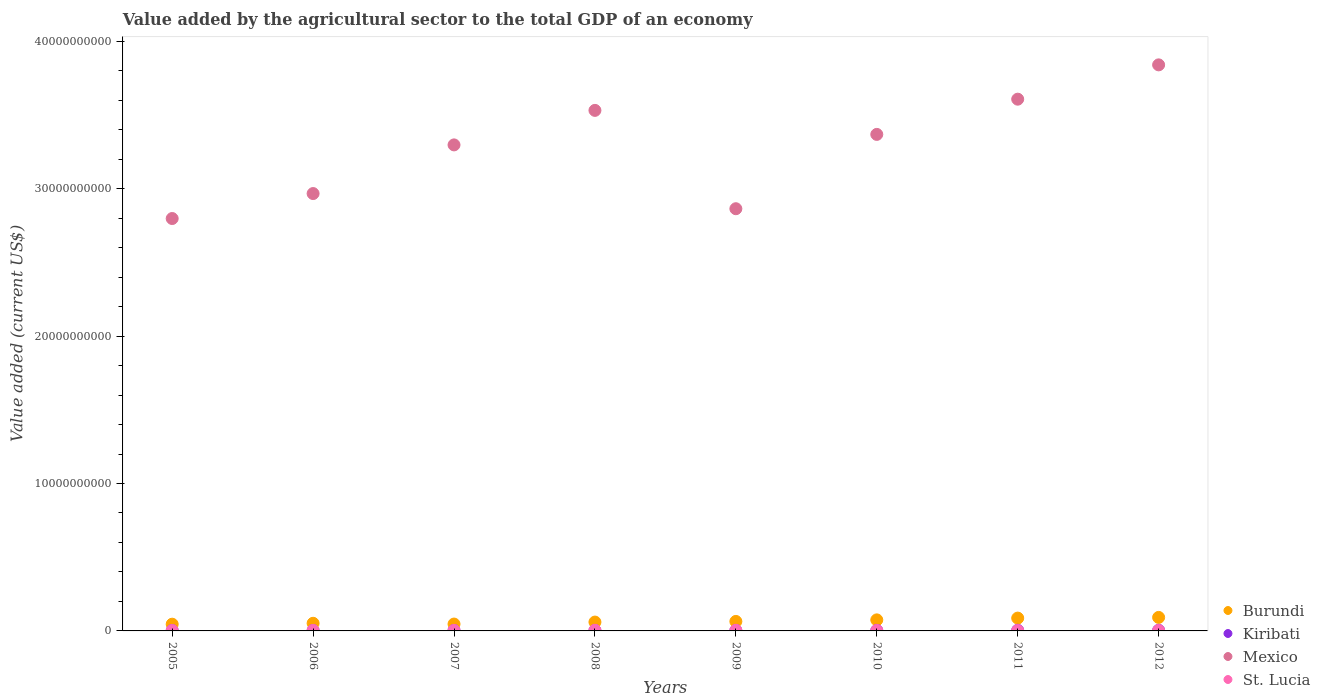Is the number of dotlines equal to the number of legend labels?
Your response must be concise. Yes. What is the value added by the agricultural sector to the total GDP in Kiribati in 2005?
Give a very brief answer. 2.30e+07. Across all years, what is the maximum value added by the agricultural sector to the total GDP in Kiribati?
Provide a succinct answer. 4.35e+07. Across all years, what is the minimum value added by the agricultural sector to the total GDP in St. Lucia?
Your answer should be very brief. 2.80e+07. In which year was the value added by the agricultural sector to the total GDP in Burundi maximum?
Your answer should be very brief. 2012. What is the total value added by the agricultural sector to the total GDP in Burundi in the graph?
Ensure brevity in your answer.  5.22e+09. What is the difference between the value added by the agricultural sector to the total GDP in Kiribati in 2005 and that in 2010?
Keep it short and to the point. -1.31e+07. What is the difference between the value added by the agricultural sector to the total GDP in Mexico in 2006 and the value added by the agricultural sector to the total GDP in Kiribati in 2011?
Offer a terse response. 2.96e+1. What is the average value added by the agricultural sector to the total GDP in Mexico per year?
Keep it short and to the point. 3.28e+1. In the year 2009, what is the difference between the value added by the agricultural sector to the total GDP in Kiribati and value added by the agricultural sector to the total GDP in Burundi?
Provide a succinct answer. -6.13e+08. What is the ratio of the value added by the agricultural sector to the total GDP in Burundi in 2007 to that in 2010?
Your answer should be compact. 0.62. Is the difference between the value added by the agricultural sector to the total GDP in Kiribati in 2010 and 2012 greater than the difference between the value added by the agricultural sector to the total GDP in Burundi in 2010 and 2012?
Your answer should be very brief. Yes. What is the difference between the highest and the second highest value added by the agricultural sector to the total GDP in Burundi?
Provide a short and direct response. 4.72e+07. What is the difference between the highest and the lowest value added by the agricultural sector to the total GDP in St. Lucia?
Your answer should be compact. 1.63e+07. Is it the case that in every year, the sum of the value added by the agricultural sector to the total GDP in St. Lucia and value added by the agricultural sector to the total GDP in Burundi  is greater than the sum of value added by the agricultural sector to the total GDP in Kiribati and value added by the agricultural sector to the total GDP in Mexico?
Make the answer very short. No. Is it the case that in every year, the sum of the value added by the agricultural sector to the total GDP in St. Lucia and value added by the agricultural sector to the total GDP in Kiribati  is greater than the value added by the agricultural sector to the total GDP in Burundi?
Provide a short and direct response. No. Does the value added by the agricultural sector to the total GDP in St. Lucia monotonically increase over the years?
Provide a short and direct response. No. Is the value added by the agricultural sector to the total GDP in Kiribati strictly greater than the value added by the agricultural sector to the total GDP in Burundi over the years?
Offer a terse response. No. Is the value added by the agricultural sector to the total GDP in St. Lucia strictly less than the value added by the agricultural sector to the total GDP in Mexico over the years?
Your response must be concise. Yes. What is the difference between two consecutive major ticks on the Y-axis?
Your answer should be compact. 1.00e+1. Are the values on the major ticks of Y-axis written in scientific E-notation?
Keep it short and to the point. No. Where does the legend appear in the graph?
Your response must be concise. Bottom right. How many legend labels are there?
Offer a terse response. 4. What is the title of the graph?
Offer a terse response. Value added by the agricultural sector to the total GDP of an economy. Does "Europe(all income levels)" appear as one of the legend labels in the graph?
Give a very brief answer. No. What is the label or title of the Y-axis?
Offer a very short reply. Value added (current US$). What is the Value added (current US$) in Burundi in 2005?
Keep it short and to the point. 4.56e+08. What is the Value added (current US$) of Kiribati in 2005?
Keep it short and to the point. 2.30e+07. What is the Value added (current US$) in Mexico in 2005?
Provide a succinct answer. 2.80e+1. What is the Value added (current US$) in St. Lucia in 2005?
Your response must be concise. 2.80e+07. What is the Value added (current US$) in Burundi in 2006?
Give a very brief answer. 5.17e+08. What is the Value added (current US$) of Kiribati in 2006?
Offer a very short reply. 2.31e+07. What is the Value added (current US$) in Mexico in 2006?
Make the answer very short. 2.97e+1. What is the Value added (current US$) in St. Lucia in 2006?
Keep it short and to the point. 3.25e+07. What is the Value added (current US$) of Burundi in 2007?
Your answer should be very brief. 4.66e+08. What is the Value added (current US$) in Kiribati in 2007?
Your response must be concise. 2.83e+07. What is the Value added (current US$) in Mexico in 2007?
Keep it short and to the point. 3.30e+1. What is the Value added (current US$) in St. Lucia in 2007?
Offer a terse response. 3.23e+07. What is the Value added (current US$) in Burundi in 2008?
Your response must be concise. 6.00e+08. What is the Value added (current US$) in Kiribati in 2008?
Ensure brevity in your answer.  3.30e+07. What is the Value added (current US$) of Mexico in 2008?
Offer a very short reply. 3.53e+1. What is the Value added (current US$) in St. Lucia in 2008?
Provide a short and direct response. 4.43e+07. What is the Value added (current US$) in Burundi in 2009?
Provide a short and direct response. 6.44e+08. What is the Value added (current US$) in Kiribati in 2009?
Ensure brevity in your answer.  3.06e+07. What is the Value added (current US$) in Mexico in 2009?
Ensure brevity in your answer.  2.86e+1. What is the Value added (current US$) of St. Lucia in 2009?
Make the answer very short. 4.25e+07. What is the Value added (current US$) in Burundi in 2010?
Keep it short and to the point. 7.49e+08. What is the Value added (current US$) in Kiribati in 2010?
Keep it short and to the point. 3.61e+07. What is the Value added (current US$) of Mexico in 2010?
Ensure brevity in your answer.  3.37e+1. What is the Value added (current US$) in St. Lucia in 2010?
Your answer should be compact. 3.16e+07. What is the Value added (current US$) in Burundi in 2011?
Your answer should be very brief. 8.69e+08. What is the Value added (current US$) in Kiribati in 2011?
Keep it short and to the point. 4.33e+07. What is the Value added (current US$) in Mexico in 2011?
Your answer should be compact. 3.61e+1. What is the Value added (current US$) in St. Lucia in 2011?
Your answer should be very brief. 2.84e+07. What is the Value added (current US$) in Burundi in 2012?
Your response must be concise. 9.16e+08. What is the Value added (current US$) of Kiribati in 2012?
Offer a terse response. 4.35e+07. What is the Value added (current US$) in Mexico in 2012?
Keep it short and to the point. 3.84e+1. What is the Value added (current US$) of St. Lucia in 2012?
Give a very brief answer. 3.24e+07. Across all years, what is the maximum Value added (current US$) of Burundi?
Your response must be concise. 9.16e+08. Across all years, what is the maximum Value added (current US$) in Kiribati?
Give a very brief answer. 4.35e+07. Across all years, what is the maximum Value added (current US$) in Mexico?
Your answer should be compact. 3.84e+1. Across all years, what is the maximum Value added (current US$) of St. Lucia?
Make the answer very short. 4.43e+07. Across all years, what is the minimum Value added (current US$) of Burundi?
Provide a succinct answer. 4.56e+08. Across all years, what is the minimum Value added (current US$) in Kiribati?
Your answer should be compact. 2.30e+07. Across all years, what is the minimum Value added (current US$) of Mexico?
Offer a very short reply. 2.80e+1. Across all years, what is the minimum Value added (current US$) in St. Lucia?
Provide a short and direct response. 2.80e+07. What is the total Value added (current US$) in Burundi in the graph?
Give a very brief answer. 5.22e+09. What is the total Value added (current US$) in Kiribati in the graph?
Your answer should be very brief. 2.61e+08. What is the total Value added (current US$) of Mexico in the graph?
Offer a terse response. 2.63e+11. What is the total Value added (current US$) of St. Lucia in the graph?
Make the answer very short. 2.72e+08. What is the difference between the Value added (current US$) of Burundi in 2005 and that in 2006?
Give a very brief answer. -6.11e+07. What is the difference between the Value added (current US$) in Kiribati in 2005 and that in 2006?
Your response must be concise. -1.69e+05. What is the difference between the Value added (current US$) of Mexico in 2005 and that in 2006?
Offer a very short reply. -1.69e+09. What is the difference between the Value added (current US$) in St. Lucia in 2005 and that in 2006?
Keep it short and to the point. -4.56e+06. What is the difference between the Value added (current US$) of Burundi in 2005 and that in 2007?
Keep it short and to the point. -9.49e+06. What is the difference between the Value added (current US$) in Kiribati in 2005 and that in 2007?
Offer a terse response. -5.39e+06. What is the difference between the Value added (current US$) in Mexico in 2005 and that in 2007?
Provide a succinct answer. -4.99e+09. What is the difference between the Value added (current US$) in St. Lucia in 2005 and that in 2007?
Offer a very short reply. -4.31e+06. What is the difference between the Value added (current US$) of Burundi in 2005 and that in 2008?
Ensure brevity in your answer.  -1.44e+08. What is the difference between the Value added (current US$) in Kiribati in 2005 and that in 2008?
Keep it short and to the point. -1.01e+07. What is the difference between the Value added (current US$) in Mexico in 2005 and that in 2008?
Offer a very short reply. -7.34e+09. What is the difference between the Value added (current US$) in St. Lucia in 2005 and that in 2008?
Your response must be concise. -1.63e+07. What is the difference between the Value added (current US$) in Burundi in 2005 and that in 2009?
Offer a terse response. -1.87e+08. What is the difference between the Value added (current US$) in Kiribati in 2005 and that in 2009?
Provide a succinct answer. -7.61e+06. What is the difference between the Value added (current US$) of Mexico in 2005 and that in 2009?
Your answer should be very brief. -6.65e+08. What is the difference between the Value added (current US$) of St. Lucia in 2005 and that in 2009?
Give a very brief answer. -1.45e+07. What is the difference between the Value added (current US$) in Burundi in 2005 and that in 2010?
Your response must be concise. -2.93e+08. What is the difference between the Value added (current US$) of Kiribati in 2005 and that in 2010?
Offer a very short reply. -1.31e+07. What is the difference between the Value added (current US$) of Mexico in 2005 and that in 2010?
Your answer should be very brief. -5.71e+09. What is the difference between the Value added (current US$) of St. Lucia in 2005 and that in 2010?
Make the answer very short. -3.60e+06. What is the difference between the Value added (current US$) in Burundi in 2005 and that in 2011?
Make the answer very short. -4.13e+08. What is the difference between the Value added (current US$) of Kiribati in 2005 and that in 2011?
Provide a short and direct response. -2.04e+07. What is the difference between the Value added (current US$) of Mexico in 2005 and that in 2011?
Keep it short and to the point. -8.10e+09. What is the difference between the Value added (current US$) of St. Lucia in 2005 and that in 2011?
Offer a terse response. -3.88e+05. What is the difference between the Value added (current US$) in Burundi in 2005 and that in 2012?
Provide a succinct answer. -4.60e+08. What is the difference between the Value added (current US$) in Kiribati in 2005 and that in 2012?
Make the answer very short. -2.05e+07. What is the difference between the Value added (current US$) in Mexico in 2005 and that in 2012?
Your answer should be very brief. -1.04e+1. What is the difference between the Value added (current US$) of St. Lucia in 2005 and that in 2012?
Give a very brief answer. -4.44e+06. What is the difference between the Value added (current US$) in Burundi in 2006 and that in 2007?
Give a very brief answer. 5.16e+07. What is the difference between the Value added (current US$) in Kiribati in 2006 and that in 2007?
Offer a terse response. -5.23e+06. What is the difference between the Value added (current US$) of Mexico in 2006 and that in 2007?
Give a very brief answer. -3.30e+09. What is the difference between the Value added (current US$) in St. Lucia in 2006 and that in 2007?
Your answer should be very brief. 2.52e+05. What is the difference between the Value added (current US$) in Burundi in 2006 and that in 2008?
Make the answer very short. -8.27e+07. What is the difference between the Value added (current US$) of Kiribati in 2006 and that in 2008?
Your answer should be very brief. -9.93e+06. What is the difference between the Value added (current US$) in Mexico in 2006 and that in 2008?
Provide a succinct answer. -5.64e+09. What is the difference between the Value added (current US$) in St. Lucia in 2006 and that in 2008?
Your response must be concise. -1.17e+07. What is the difference between the Value added (current US$) of Burundi in 2006 and that in 2009?
Provide a succinct answer. -1.26e+08. What is the difference between the Value added (current US$) of Kiribati in 2006 and that in 2009?
Offer a very short reply. -7.44e+06. What is the difference between the Value added (current US$) in Mexico in 2006 and that in 2009?
Provide a succinct answer. 1.03e+09. What is the difference between the Value added (current US$) of St. Lucia in 2006 and that in 2009?
Make the answer very short. -9.91e+06. What is the difference between the Value added (current US$) of Burundi in 2006 and that in 2010?
Your answer should be very brief. -2.32e+08. What is the difference between the Value added (current US$) of Kiribati in 2006 and that in 2010?
Make the answer very short. -1.29e+07. What is the difference between the Value added (current US$) in Mexico in 2006 and that in 2010?
Your response must be concise. -4.01e+09. What is the difference between the Value added (current US$) in St. Lucia in 2006 and that in 2010?
Provide a short and direct response. 9.56e+05. What is the difference between the Value added (current US$) in Burundi in 2006 and that in 2011?
Ensure brevity in your answer.  -3.52e+08. What is the difference between the Value added (current US$) of Kiribati in 2006 and that in 2011?
Your answer should be very brief. -2.02e+07. What is the difference between the Value added (current US$) in Mexico in 2006 and that in 2011?
Your response must be concise. -6.40e+09. What is the difference between the Value added (current US$) of St. Lucia in 2006 and that in 2011?
Keep it short and to the point. 4.17e+06. What is the difference between the Value added (current US$) of Burundi in 2006 and that in 2012?
Offer a very short reply. -3.99e+08. What is the difference between the Value added (current US$) in Kiribati in 2006 and that in 2012?
Ensure brevity in your answer.  -2.04e+07. What is the difference between the Value added (current US$) of Mexico in 2006 and that in 2012?
Your answer should be compact. -8.73e+09. What is the difference between the Value added (current US$) of St. Lucia in 2006 and that in 2012?
Your response must be concise. 1.19e+05. What is the difference between the Value added (current US$) of Burundi in 2007 and that in 2008?
Give a very brief answer. -1.34e+08. What is the difference between the Value added (current US$) of Kiribati in 2007 and that in 2008?
Keep it short and to the point. -4.70e+06. What is the difference between the Value added (current US$) in Mexico in 2007 and that in 2008?
Your answer should be compact. -2.34e+09. What is the difference between the Value added (current US$) of St. Lucia in 2007 and that in 2008?
Your answer should be very brief. -1.20e+07. What is the difference between the Value added (current US$) in Burundi in 2007 and that in 2009?
Your answer should be compact. -1.78e+08. What is the difference between the Value added (current US$) of Kiribati in 2007 and that in 2009?
Keep it short and to the point. -2.21e+06. What is the difference between the Value added (current US$) of Mexico in 2007 and that in 2009?
Give a very brief answer. 4.33e+09. What is the difference between the Value added (current US$) in St. Lucia in 2007 and that in 2009?
Your answer should be very brief. -1.02e+07. What is the difference between the Value added (current US$) of Burundi in 2007 and that in 2010?
Offer a terse response. -2.83e+08. What is the difference between the Value added (current US$) of Kiribati in 2007 and that in 2010?
Offer a terse response. -7.71e+06. What is the difference between the Value added (current US$) of Mexico in 2007 and that in 2010?
Offer a terse response. -7.12e+08. What is the difference between the Value added (current US$) in St. Lucia in 2007 and that in 2010?
Your response must be concise. 7.04e+05. What is the difference between the Value added (current US$) in Burundi in 2007 and that in 2011?
Provide a short and direct response. -4.03e+08. What is the difference between the Value added (current US$) of Kiribati in 2007 and that in 2011?
Ensure brevity in your answer.  -1.50e+07. What is the difference between the Value added (current US$) in Mexico in 2007 and that in 2011?
Make the answer very short. -3.10e+09. What is the difference between the Value added (current US$) in St. Lucia in 2007 and that in 2011?
Ensure brevity in your answer.  3.92e+06. What is the difference between the Value added (current US$) in Burundi in 2007 and that in 2012?
Offer a very short reply. -4.51e+08. What is the difference between the Value added (current US$) in Kiribati in 2007 and that in 2012?
Your answer should be compact. -1.51e+07. What is the difference between the Value added (current US$) of Mexico in 2007 and that in 2012?
Your answer should be compact. -5.43e+09. What is the difference between the Value added (current US$) of St. Lucia in 2007 and that in 2012?
Make the answer very short. -1.34e+05. What is the difference between the Value added (current US$) of Burundi in 2008 and that in 2009?
Provide a succinct answer. -4.35e+07. What is the difference between the Value added (current US$) of Kiribati in 2008 and that in 2009?
Give a very brief answer. 2.49e+06. What is the difference between the Value added (current US$) in Mexico in 2008 and that in 2009?
Your answer should be very brief. 6.67e+09. What is the difference between the Value added (current US$) in St. Lucia in 2008 and that in 2009?
Make the answer very short. 1.83e+06. What is the difference between the Value added (current US$) of Burundi in 2008 and that in 2010?
Provide a succinct answer. -1.49e+08. What is the difference between the Value added (current US$) in Kiribati in 2008 and that in 2010?
Provide a short and direct response. -3.01e+06. What is the difference between the Value added (current US$) of Mexico in 2008 and that in 2010?
Offer a terse response. 1.63e+09. What is the difference between the Value added (current US$) in St. Lucia in 2008 and that in 2010?
Give a very brief answer. 1.27e+07. What is the difference between the Value added (current US$) in Burundi in 2008 and that in 2011?
Provide a short and direct response. -2.69e+08. What is the difference between the Value added (current US$) of Kiribati in 2008 and that in 2011?
Provide a short and direct response. -1.03e+07. What is the difference between the Value added (current US$) of Mexico in 2008 and that in 2011?
Your answer should be compact. -7.60e+08. What is the difference between the Value added (current US$) in St. Lucia in 2008 and that in 2011?
Keep it short and to the point. 1.59e+07. What is the difference between the Value added (current US$) of Burundi in 2008 and that in 2012?
Your answer should be very brief. -3.16e+08. What is the difference between the Value added (current US$) in Kiribati in 2008 and that in 2012?
Your answer should be very brief. -1.04e+07. What is the difference between the Value added (current US$) in Mexico in 2008 and that in 2012?
Your response must be concise. -3.09e+09. What is the difference between the Value added (current US$) of St. Lucia in 2008 and that in 2012?
Your response must be concise. 1.19e+07. What is the difference between the Value added (current US$) of Burundi in 2009 and that in 2010?
Your answer should be compact. -1.06e+08. What is the difference between the Value added (current US$) of Kiribati in 2009 and that in 2010?
Keep it short and to the point. -5.49e+06. What is the difference between the Value added (current US$) of Mexico in 2009 and that in 2010?
Your answer should be compact. -5.04e+09. What is the difference between the Value added (current US$) in St. Lucia in 2009 and that in 2010?
Give a very brief answer. 1.09e+07. What is the difference between the Value added (current US$) in Burundi in 2009 and that in 2011?
Ensure brevity in your answer.  -2.26e+08. What is the difference between the Value added (current US$) of Kiribati in 2009 and that in 2011?
Your answer should be compact. -1.28e+07. What is the difference between the Value added (current US$) in Mexico in 2009 and that in 2011?
Offer a terse response. -7.43e+09. What is the difference between the Value added (current US$) of St. Lucia in 2009 and that in 2011?
Offer a very short reply. 1.41e+07. What is the difference between the Value added (current US$) in Burundi in 2009 and that in 2012?
Your response must be concise. -2.73e+08. What is the difference between the Value added (current US$) in Kiribati in 2009 and that in 2012?
Ensure brevity in your answer.  -1.29e+07. What is the difference between the Value added (current US$) in Mexico in 2009 and that in 2012?
Provide a short and direct response. -9.76e+09. What is the difference between the Value added (current US$) of St. Lucia in 2009 and that in 2012?
Give a very brief answer. 1.00e+07. What is the difference between the Value added (current US$) of Burundi in 2010 and that in 2011?
Ensure brevity in your answer.  -1.20e+08. What is the difference between the Value added (current US$) in Kiribati in 2010 and that in 2011?
Keep it short and to the point. -7.26e+06. What is the difference between the Value added (current US$) of Mexico in 2010 and that in 2011?
Offer a terse response. -2.39e+09. What is the difference between the Value added (current US$) of St. Lucia in 2010 and that in 2011?
Make the answer very short. 3.22e+06. What is the difference between the Value added (current US$) in Burundi in 2010 and that in 2012?
Make the answer very short. -1.67e+08. What is the difference between the Value added (current US$) of Kiribati in 2010 and that in 2012?
Make the answer very short. -7.43e+06. What is the difference between the Value added (current US$) in Mexico in 2010 and that in 2012?
Provide a succinct answer. -4.72e+09. What is the difference between the Value added (current US$) of St. Lucia in 2010 and that in 2012?
Keep it short and to the point. -8.38e+05. What is the difference between the Value added (current US$) in Burundi in 2011 and that in 2012?
Your answer should be compact. -4.72e+07. What is the difference between the Value added (current US$) in Kiribati in 2011 and that in 2012?
Give a very brief answer. -1.66e+05. What is the difference between the Value added (current US$) of Mexico in 2011 and that in 2012?
Provide a succinct answer. -2.33e+09. What is the difference between the Value added (current US$) in St. Lucia in 2011 and that in 2012?
Provide a succinct answer. -4.05e+06. What is the difference between the Value added (current US$) in Burundi in 2005 and the Value added (current US$) in Kiribati in 2006?
Ensure brevity in your answer.  4.33e+08. What is the difference between the Value added (current US$) of Burundi in 2005 and the Value added (current US$) of Mexico in 2006?
Offer a terse response. -2.92e+1. What is the difference between the Value added (current US$) of Burundi in 2005 and the Value added (current US$) of St. Lucia in 2006?
Your answer should be compact. 4.24e+08. What is the difference between the Value added (current US$) in Kiribati in 2005 and the Value added (current US$) in Mexico in 2006?
Give a very brief answer. -2.96e+1. What is the difference between the Value added (current US$) in Kiribati in 2005 and the Value added (current US$) in St. Lucia in 2006?
Offer a terse response. -9.59e+06. What is the difference between the Value added (current US$) in Mexico in 2005 and the Value added (current US$) in St. Lucia in 2006?
Offer a terse response. 2.79e+1. What is the difference between the Value added (current US$) of Burundi in 2005 and the Value added (current US$) of Kiribati in 2007?
Your answer should be compact. 4.28e+08. What is the difference between the Value added (current US$) in Burundi in 2005 and the Value added (current US$) in Mexico in 2007?
Provide a short and direct response. -3.25e+1. What is the difference between the Value added (current US$) in Burundi in 2005 and the Value added (current US$) in St. Lucia in 2007?
Make the answer very short. 4.24e+08. What is the difference between the Value added (current US$) in Kiribati in 2005 and the Value added (current US$) in Mexico in 2007?
Ensure brevity in your answer.  -3.29e+1. What is the difference between the Value added (current US$) in Kiribati in 2005 and the Value added (current US$) in St. Lucia in 2007?
Provide a succinct answer. -9.34e+06. What is the difference between the Value added (current US$) in Mexico in 2005 and the Value added (current US$) in St. Lucia in 2007?
Your answer should be compact. 2.79e+1. What is the difference between the Value added (current US$) in Burundi in 2005 and the Value added (current US$) in Kiribati in 2008?
Your answer should be compact. 4.23e+08. What is the difference between the Value added (current US$) in Burundi in 2005 and the Value added (current US$) in Mexico in 2008?
Your answer should be very brief. -3.49e+1. What is the difference between the Value added (current US$) in Burundi in 2005 and the Value added (current US$) in St. Lucia in 2008?
Make the answer very short. 4.12e+08. What is the difference between the Value added (current US$) of Kiribati in 2005 and the Value added (current US$) of Mexico in 2008?
Your response must be concise. -3.53e+1. What is the difference between the Value added (current US$) of Kiribati in 2005 and the Value added (current US$) of St. Lucia in 2008?
Your response must be concise. -2.13e+07. What is the difference between the Value added (current US$) of Mexico in 2005 and the Value added (current US$) of St. Lucia in 2008?
Your answer should be compact. 2.79e+1. What is the difference between the Value added (current US$) of Burundi in 2005 and the Value added (current US$) of Kiribati in 2009?
Provide a succinct answer. 4.26e+08. What is the difference between the Value added (current US$) in Burundi in 2005 and the Value added (current US$) in Mexico in 2009?
Your answer should be very brief. -2.82e+1. What is the difference between the Value added (current US$) in Burundi in 2005 and the Value added (current US$) in St. Lucia in 2009?
Give a very brief answer. 4.14e+08. What is the difference between the Value added (current US$) in Kiribati in 2005 and the Value added (current US$) in Mexico in 2009?
Your answer should be very brief. -2.86e+1. What is the difference between the Value added (current US$) of Kiribati in 2005 and the Value added (current US$) of St. Lucia in 2009?
Offer a terse response. -1.95e+07. What is the difference between the Value added (current US$) in Mexico in 2005 and the Value added (current US$) in St. Lucia in 2009?
Provide a short and direct response. 2.79e+1. What is the difference between the Value added (current US$) of Burundi in 2005 and the Value added (current US$) of Kiribati in 2010?
Offer a very short reply. 4.20e+08. What is the difference between the Value added (current US$) in Burundi in 2005 and the Value added (current US$) in Mexico in 2010?
Provide a succinct answer. -3.32e+1. What is the difference between the Value added (current US$) in Burundi in 2005 and the Value added (current US$) in St. Lucia in 2010?
Ensure brevity in your answer.  4.25e+08. What is the difference between the Value added (current US$) in Kiribati in 2005 and the Value added (current US$) in Mexico in 2010?
Your answer should be very brief. -3.37e+1. What is the difference between the Value added (current US$) in Kiribati in 2005 and the Value added (current US$) in St. Lucia in 2010?
Give a very brief answer. -8.63e+06. What is the difference between the Value added (current US$) of Mexico in 2005 and the Value added (current US$) of St. Lucia in 2010?
Your response must be concise. 2.79e+1. What is the difference between the Value added (current US$) in Burundi in 2005 and the Value added (current US$) in Kiribati in 2011?
Your answer should be very brief. 4.13e+08. What is the difference between the Value added (current US$) in Burundi in 2005 and the Value added (current US$) in Mexico in 2011?
Provide a succinct answer. -3.56e+1. What is the difference between the Value added (current US$) of Burundi in 2005 and the Value added (current US$) of St. Lucia in 2011?
Provide a succinct answer. 4.28e+08. What is the difference between the Value added (current US$) of Kiribati in 2005 and the Value added (current US$) of Mexico in 2011?
Provide a succinct answer. -3.60e+1. What is the difference between the Value added (current US$) in Kiribati in 2005 and the Value added (current US$) in St. Lucia in 2011?
Keep it short and to the point. -5.42e+06. What is the difference between the Value added (current US$) in Mexico in 2005 and the Value added (current US$) in St. Lucia in 2011?
Ensure brevity in your answer.  2.79e+1. What is the difference between the Value added (current US$) in Burundi in 2005 and the Value added (current US$) in Kiribati in 2012?
Provide a succinct answer. 4.13e+08. What is the difference between the Value added (current US$) in Burundi in 2005 and the Value added (current US$) in Mexico in 2012?
Give a very brief answer. -3.79e+1. What is the difference between the Value added (current US$) in Burundi in 2005 and the Value added (current US$) in St. Lucia in 2012?
Make the answer very short. 4.24e+08. What is the difference between the Value added (current US$) in Kiribati in 2005 and the Value added (current US$) in Mexico in 2012?
Your answer should be compact. -3.84e+1. What is the difference between the Value added (current US$) in Kiribati in 2005 and the Value added (current US$) in St. Lucia in 2012?
Your response must be concise. -9.47e+06. What is the difference between the Value added (current US$) in Mexico in 2005 and the Value added (current US$) in St. Lucia in 2012?
Offer a very short reply. 2.79e+1. What is the difference between the Value added (current US$) in Burundi in 2006 and the Value added (current US$) in Kiribati in 2007?
Make the answer very short. 4.89e+08. What is the difference between the Value added (current US$) of Burundi in 2006 and the Value added (current US$) of Mexico in 2007?
Give a very brief answer. -3.25e+1. What is the difference between the Value added (current US$) in Burundi in 2006 and the Value added (current US$) in St. Lucia in 2007?
Provide a succinct answer. 4.85e+08. What is the difference between the Value added (current US$) of Kiribati in 2006 and the Value added (current US$) of Mexico in 2007?
Keep it short and to the point. -3.29e+1. What is the difference between the Value added (current US$) of Kiribati in 2006 and the Value added (current US$) of St. Lucia in 2007?
Offer a terse response. -9.17e+06. What is the difference between the Value added (current US$) of Mexico in 2006 and the Value added (current US$) of St. Lucia in 2007?
Your answer should be very brief. 2.96e+1. What is the difference between the Value added (current US$) of Burundi in 2006 and the Value added (current US$) of Kiribati in 2008?
Keep it short and to the point. 4.84e+08. What is the difference between the Value added (current US$) of Burundi in 2006 and the Value added (current US$) of Mexico in 2008?
Your answer should be compact. -3.48e+1. What is the difference between the Value added (current US$) of Burundi in 2006 and the Value added (current US$) of St. Lucia in 2008?
Give a very brief answer. 4.73e+08. What is the difference between the Value added (current US$) of Kiribati in 2006 and the Value added (current US$) of Mexico in 2008?
Make the answer very short. -3.53e+1. What is the difference between the Value added (current US$) of Kiribati in 2006 and the Value added (current US$) of St. Lucia in 2008?
Give a very brief answer. -2.12e+07. What is the difference between the Value added (current US$) of Mexico in 2006 and the Value added (current US$) of St. Lucia in 2008?
Provide a short and direct response. 2.96e+1. What is the difference between the Value added (current US$) in Burundi in 2006 and the Value added (current US$) in Kiribati in 2009?
Provide a succinct answer. 4.87e+08. What is the difference between the Value added (current US$) of Burundi in 2006 and the Value added (current US$) of Mexico in 2009?
Offer a very short reply. -2.81e+1. What is the difference between the Value added (current US$) in Burundi in 2006 and the Value added (current US$) in St. Lucia in 2009?
Your answer should be compact. 4.75e+08. What is the difference between the Value added (current US$) of Kiribati in 2006 and the Value added (current US$) of Mexico in 2009?
Provide a short and direct response. -2.86e+1. What is the difference between the Value added (current US$) of Kiribati in 2006 and the Value added (current US$) of St. Lucia in 2009?
Keep it short and to the point. -1.93e+07. What is the difference between the Value added (current US$) in Mexico in 2006 and the Value added (current US$) in St. Lucia in 2009?
Keep it short and to the point. 2.96e+1. What is the difference between the Value added (current US$) of Burundi in 2006 and the Value added (current US$) of Kiribati in 2010?
Provide a short and direct response. 4.81e+08. What is the difference between the Value added (current US$) of Burundi in 2006 and the Value added (current US$) of Mexico in 2010?
Ensure brevity in your answer.  -3.32e+1. What is the difference between the Value added (current US$) of Burundi in 2006 and the Value added (current US$) of St. Lucia in 2010?
Provide a succinct answer. 4.86e+08. What is the difference between the Value added (current US$) of Kiribati in 2006 and the Value added (current US$) of Mexico in 2010?
Your answer should be very brief. -3.37e+1. What is the difference between the Value added (current US$) in Kiribati in 2006 and the Value added (current US$) in St. Lucia in 2010?
Provide a short and direct response. -8.47e+06. What is the difference between the Value added (current US$) of Mexico in 2006 and the Value added (current US$) of St. Lucia in 2010?
Keep it short and to the point. 2.96e+1. What is the difference between the Value added (current US$) of Burundi in 2006 and the Value added (current US$) of Kiribati in 2011?
Provide a short and direct response. 4.74e+08. What is the difference between the Value added (current US$) of Burundi in 2006 and the Value added (current US$) of Mexico in 2011?
Your answer should be compact. -3.56e+1. What is the difference between the Value added (current US$) in Burundi in 2006 and the Value added (current US$) in St. Lucia in 2011?
Give a very brief answer. 4.89e+08. What is the difference between the Value added (current US$) in Kiribati in 2006 and the Value added (current US$) in Mexico in 2011?
Offer a terse response. -3.60e+1. What is the difference between the Value added (current US$) of Kiribati in 2006 and the Value added (current US$) of St. Lucia in 2011?
Give a very brief answer. -5.25e+06. What is the difference between the Value added (current US$) in Mexico in 2006 and the Value added (current US$) in St. Lucia in 2011?
Your answer should be very brief. 2.96e+1. What is the difference between the Value added (current US$) in Burundi in 2006 and the Value added (current US$) in Kiribati in 2012?
Offer a terse response. 4.74e+08. What is the difference between the Value added (current US$) of Burundi in 2006 and the Value added (current US$) of Mexico in 2012?
Offer a terse response. -3.79e+1. What is the difference between the Value added (current US$) of Burundi in 2006 and the Value added (current US$) of St. Lucia in 2012?
Your answer should be compact. 4.85e+08. What is the difference between the Value added (current US$) of Kiribati in 2006 and the Value added (current US$) of Mexico in 2012?
Your answer should be very brief. -3.84e+1. What is the difference between the Value added (current US$) in Kiribati in 2006 and the Value added (current US$) in St. Lucia in 2012?
Provide a short and direct response. -9.30e+06. What is the difference between the Value added (current US$) in Mexico in 2006 and the Value added (current US$) in St. Lucia in 2012?
Offer a terse response. 2.96e+1. What is the difference between the Value added (current US$) of Burundi in 2007 and the Value added (current US$) of Kiribati in 2008?
Your response must be concise. 4.33e+08. What is the difference between the Value added (current US$) of Burundi in 2007 and the Value added (current US$) of Mexico in 2008?
Give a very brief answer. -3.48e+1. What is the difference between the Value added (current US$) in Burundi in 2007 and the Value added (current US$) in St. Lucia in 2008?
Offer a terse response. 4.22e+08. What is the difference between the Value added (current US$) of Kiribati in 2007 and the Value added (current US$) of Mexico in 2008?
Your answer should be very brief. -3.53e+1. What is the difference between the Value added (current US$) in Kiribati in 2007 and the Value added (current US$) in St. Lucia in 2008?
Provide a succinct answer. -1.59e+07. What is the difference between the Value added (current US$) of Mexico in 2007 and the Value added (current US$) of St. Lucia in 2008?
Your answer should be compact. 3.29e+1. What is the difference between the Value added (current US$) of Burundi in 2007 and the Value added (current US$) of Kiribati in 2009?
Your answer should be very brief. 4.35e+08. What is the difference between the Value added (current US$) in Burundi in 2007 and the Value added (current US$) in Mexico in 2009?
Your answer should be very brief. -2.82e+1. What is the difference between the Value added (current US$) in Burundi in 2007 and the Value added (current US$) in St. Lucia in 2009?
Give a very brief answer. 4.23e+08. What is the difference between the Value added (current US$) in Kiribati in 2007 and the Value added (current US$) in Mexico in 2009?
Keep it short and to the point. -2.86e+1. What is the difference between the Value added (current US$) of Kiribati in 2007 and the Value added (current US$) of St. Lucia in 2009?
Provide a short and direct response. -1.41e+07. What is the difference between the Value added (current US$) of Mexico in 2007 and the Value added (current US$) of St. Lucia in 2009?
Give a very brief answer. 3.29e+1. What is the difference between the Value added (current US$) in Burundi in 2007 and the Value added (current US$) in Kiribati in 2010?
Your answer should be very brief. 4.30e+08. What is the difference between the Value added (current US$) in Burundi in 2007 and the Value added (current US$) in Mexico in 2010?
Provide a short and direct response. -3.32e+1. What is the difference between the Value added (current US$) in Burundi in 2007 and the Value added (current US$) in St. Lucia in 2010?
Your answer should be compact. 4.34e+08. What is the difference between the Value added (current US$) of Kiribati in 2007 and the Value added (current US$) of Mexico in 2010?
Provide a short and direct response. -3.37e+1. What is the difference between the Value added (current US$) in Kiribati in 2007 and the Value added (current US$) in St. Lucia in 2010?
Offer a terse response. -3.24e+06. What is the difference between the Value added (current US$) in Mexico in 2007 and the Value added (current US$) in St. Lucia in 2010?
Make the answer very short. 3.29e+1. What is the difference between the Value added (current US$) of Burundi in 2007 and the Value added (current US$) of Kiribati in 2011?
Your response must be concise. 4.23e+08. What is the difference between the Value added (current US$) in Burundi in 2007 and the Value added (current US$) in Mexico in 2011?
Provide a succinct answer. -3.56e+1. What is the difference between the Value added (current US$) in Burundi in 2007 and the Value added (current US$) in St. Lucia in 2011?
Make the answer very short. 4.37e+08. What is the difference between the Value added (current US$) in Kiribati in 2007 and the Value added (current US$) in Mexico in 2011?
Give a very brief answer. -3.60e+1. What is the difference between the Value added (current US$) of Kiribati in 2007 and the Value added (current US$) of St. Lucia in 2011?
Ensure brevity in your answer.  -2.45e+04. What is the difference between the Value added (current US$) of Mexico in 2007 and the Value added (current US$) of St. Lucia in 2011?
Keep it short and to the point. 3.29e+1. What is the difference between the Value added (current US$) of Burundi in 2007 and the Value added (current US$) of Kiribati in 2012?
Provide a short and direct response. 4.22e+08. What is the difference between the Value added (current US$) in Burundi in 2007 and the Value added (current US$) in Mexico in 2012?
Offer a very short reply. -3.79e+1. What is the difference between the Value added (current US$) of Burundi in 2007 and the Value added (current US$) of St. Lucia in 2012?
Offer a terse response. 4.33e+08. What is the difference between the Value added (current US$) of Kiribati in 2007 and the Value added (current US$) of Mexico in 2012?
Make the answer very short. -3.84e+1. What is the difference between the Value added (current US$) in Kiribati in 2007 and the Value added (current US$) in St. Lucia in 2012?
Offer a terse response. -4.08e+06. What is the difference between the Value added (current US$) in Mexico in 2007 and the Value added (current US$) in St. Lucia in 2012?
Offer a very short reply. 3.29e+1. What is the difference between the Value added (current US$) of Burundi in 2008 and the Value added (current US$) of Kiribati in 2009?
Offer a terse response. 5.70e+08. What is the difference between the Value added (current US$) of Burundi in 2008 and the Value added (current US$) of Mexico in 2009?
Your answer should be very brief. -2.80e+1. What is the difference between the Value added (current US$) of Burundi in 2008 and the Value added (current US$) of St. Lucia in 2009?
Make the answer very short. 5.58e+08. What is the difference between the Value added (current US$) of Kiribati in 2008 and the Value added (current US$) of Mexico in 2009?
Keep it short and to the point. -2.86e+1. What is the difference between the Value added (current US$) of Kiribati in 2008 and the Value added (current US$) of St. Lucia in 2009?
Give a very brief answer. -9.41e+06. What is the difference between the Value added (current US$) in Mexico in 2008 and the Value added (current US$) in St. Lucia in 2009?
Your answer should be very brief. 3.53e+1. What is the difference between the Value added (current US$) in Burundi in 2008 and the Value added (current US$) in Kiribati in 2010?
Make the answer very short. 5.64e+08. What is the difference between the Value added (current US$) of Burundi in 2008 and the Value added (current US$) of Mexico in 2010?
Offer a terse response. -3.31e+1. What is the difference between the Value added (current US$) in Burundi in 2008 and the Value added (current US$) in St. Lucia in 2010?
Provide a short and direct response. 5.69e+08. What is the difference between the Value added (current US$) of Kiribati in 2008 and the Value added (current US$) of Mexico in 2010?
Offer a terse response. -3.36e+1. What is the difference between the Value added (current US$) in Kiribati in 2008 and the Value added (current US$) in St. Lucia in 2010?
Keep it short and to the point. 1.46e+06. What is the difference between the Value added (current US$) in Mexico in 2008 and the Value added (current US$) in St. Lucia in 2010?
Your answer should be very brief. 3.53e+1. What is the difference between the Value added (current US$) in Burundi in 2008 and the Value added (current US$) in Kiribati in 2011?
Provide a succinct answer. 5.57e+08. What is the difference between the Value added (current US$) in Burundi in 2008 and the Value added (current US$) in Mexico in 2011?
Provide a succinct answer. -3.55e+1. What is the difference between the Value added (current US$) in Burundi in 2008 and the Value added (current US$) in St. Lucia in 2011?
Give a very brief answer. 5.72e+08. What is the difference between the Value added (current US$) in Kiribati in 2008 and the Value added (current US$) in Mexico in 2011?
Provide a succinct answer. -3.60e+1. What is the difference between the Value added (current US$) of Kiribati in 2008 and the Value added (current US$) of St. Lucia in 2011?
Your answer should be very brief. 4.68e+06. What is the difference between the Value added (current US$) of Mexico in 2008 and the Value added (current US$) of St. Lucia in 2011?
Your response must be concise. 3.53e+1. What is the difference between the Value added (current US$) in Burundi in 2008 and the Value added (current US$) in Kiribati in 2012?
Make the answer very short. 5.57e+08. What is the difference between the Value added (current US$) of Burundi in 2008 and the Value added (current US$) of Mexico in 2012?
Offer a terse response. -3.78e+1. What is the difference between the Value added (current US$) in Burundi in 2008 and the Value added (current US$) in St. Lucia in 2012?
Your response must be concise. 5.68e+08. What is the difference between the Value added (current US$) in Kiribati in 2008 and the Value added (current US$) in Mexico in 2012?
Your answer should be very brief. -3.84e+1. What is the difference between the Value added (current US$) of Kiribati in 2008 and the Value added (current US$) of St. Lucia in 2012?
Ensure brevity in your answer.  6.22e+05. What is the difference between the Value added (current US$) in Mexico in 2008 and the Value added (current US$) in St. Lucia in 2012?
Your answer should be compact. 3.53e+1. What is the difference between the Value added (current US$) in Burundi in 2009 and the Value added (current US$) in Kiribati in 2010?
Make the answer very short. 6.08e+08. What is the difference between the Value added (current US$) in Burundi in 2009 and the Value added (current US$) in Mexico in 2010?
Ensure brevity in your answer.  -3.30e+1. What is the difference between the Value added (current US$) of Burundi in 2009 and the Value added (current US$) of St. Lucia in 2010?
Make the answer very short. 6.12e+08. What is the difference between the Value added (current US$) of Kiribati in 2009 and the Value added (current US$) of Mexico in 2010?
Your answer should be very brief. -3.37e+1. What is the difference between the Value added (current US$) in Kiribati in 2009 and the Value added (current US$) in St. Lucia in 2010?
Give a very brief answer. -1.03e+06. What is the difference between the Value added (current US$) in Mexico in 2009 and the Value added (current US$) in St. Lucia in 2010?
Make the answer very short. 2.86e+1. What is the difference between the Value added (current US$) in Burundi in 2009 and the Value added (current US$) in Kiribati in 2011?
Your answer should be very brief. 6.00e+08. What is the difference between the Value added (current US$) of Burundi in 2009 and the Value added (current US$) of Mexico in 2011?
Offer a terse response. -3.54e+1. What is the difference between the Value added (current US$) of Burundi in 2009 and the Value added (current US$) of St. Lucia in 2011?
Give a very brief answer. 6.15e+08. What is the difference between the Value added (current US$) of Kiribati in 2009 and the Value added (current US$) of Mexico in 2011?
Your response must be concise. -3.60e+1. What is the difference between the Value added (current US$) in Kiribati in 2009 and the Value added (current US$) in St. Lucia in 2011?
Offer a terse response. 2.19e+06. What is the difference between the Value added (current US$) in Mexico in 2009 and the Value added (current US$) in St. Lucia in 2011?
Make the answer very short. 2.86e+1. What is the difference between the Value added (current US$) in Burundi in 2009 and the Value added (current US$) in Kiribati in 2012?
Your answer should be compact. 6.00e+08. What is the difference between the Value added (current US$) in Burundi in 2009 and the Value added (current US$) in Mexico in 2012?
Provide a succinct answer. -3.78e+1. What is the difference between the Value added (current US$) in Burundi in 2009 and the Value added (current US$) in St. Lucia in 2012?
Keep it short and to the point. 6.11e+08. What is the difference between the Value added (current US$) of Kiribati in 2009 and the Value added (current US$) of Mexico in 2012?
Ensure brevity in your answer.  -3.84e+1. What is the difference between the Value added (current US$) of Kiribati in 2009 and the Value added (current US$) of St. Lucia in 2012?
Provide a succinct answer. -1.86e+06. What is the difference between the Value added (current US$) of Mexico in 2009 and the Value added (current US$) of St. Lucia in 2012?
Ensure brevity in your answer.  2.86e+1. What is the difference between the Value added (current US$) in Burundi in 2010 and the Value added (current US$) in Kiribati in 2011?
Provide a short and direct response. 7.06e+08. What is the difference between the Value added (current US$) in Burundi in 2010 and the Value added (current US$) in Mexico in 2011?
Your response must be concise. -3.53e+1. What is the difference between the Value added (current US$) of Burundi in 2010 and the Value added (current US$) of St. Lucia in 2011?
Ensure brevity in your answer.  7.21e+08. What is the difference between the Value added (current US$) of Kiribati in 2010 and the Value added (current US$) of Mexico in 2011?
Keep it short and to the point. -3.60e+1. What is the difference between the Value added (current US$) in Kiribati in 2010 and the Value added (current US$) in St. Lucia in 2011?
Provide a short and direct response. 7.68e+06. What is the difference between the Value added (current US$) of Mexico in 2010 and the Value added (current US$) of St. Lucia in 2011?
Ensure brevity in your answer.  3.37e+1. What is the difference between the Value added (current US$) of Burundi in 2010 and the Value added (current US$) of Kiribati in 2012?
Offer a very short reply. 7.06e+08. What is the difference between the Value added (current US$) in Burundi in 2010 and the Value added (current US$) in Mexico in 2012?
Give a very brief answer. -3.76e+1. What is the difference between the Value added (current US$) in Burundi in 2010 and the Value added (current US$) in St. Lucia in 2012?
Offer a terse response. 7.17e+08. What is the difference between the Value added (current US$) in Kiribati in 2010 and the Value added (current US$) in Mexico in 2012?
Give a very brief answer. -3.84e+1. What is the difference between the Value added (current US$) of Kiribati in 2010 and the Value added (current US$) of St. Lucia in 2012?
Ensure brevity in your answer.  3.63e+06. What is the difference between the Value added (current US$) of Mexico in 2010 and the Value added (current US$) of St. Lucia in 2012?
Your response must be concise. 3.36e+1. What is the difference between the Value added (current US$) of Burundi in 2011 and the Value added (current US$) of Kiribati in 2012?
Make the answer very short. 8.26e+08. What is the difference between the Value added (current US$) in Burundi in 2011 and the Value added (current US$) in Mexico in 2012?
Keep it short and to the point. -3.75e+1. What is the difference between the Value added (current US$) of Burundi in 2011 and the Value added (current US$) of St. Lucia in 2012?
Provide a short and direct response. 8.37e+08. What is the difference between the Value added (current US$) of Kiribati in 2011 and the Value added (current US$) of Mexico in 2012?
Provide a succinct answer. -3.84e+1. What is the difference between the Value added (current US$) in Kiribati in 2011 and the Value added (current US$) in St. Lucia in 2012?
Give a very brief answer. 1.09e+07. What is the difference between the Value added (current US$) in Mexico in 2011 and the Value added (current US$) in St. Lucia in 2012?
Your response must be concise. 3.60e+1. What is the average Value added (current US$) in Burundi per year?
Give a very brief answer. 6.52e+08. What is the average Value added (current US$) of Kiribati per year?
Provide a succinct answer. 3.26e+07. What is the average Value added (current US$) in Mexico per year?
Your answer should be very brief. 3.28e+1. What is the average Value added (current US$) of St. Lucia per year?
Your answer should be very brief. 3.40e+07. In the year 2005, what is the difference between the Value added (current US$) of Burundi and Value added (current US$) of Kiribati?
Your answer should be very brief. 4.33e+08. In the year 2005, what is the difference between the Value added (current US$) of Burundi and Value added (current US$) of Mexico?
Keep it short and to the point. -2.75e+1. In the year 2005, what is the difference between the Value added (current US$) of Burundi and Value added (current US$) of St. Lucia?
Provide a succinct answer. 4.28e+08. In the year 2005, what is the difference between the Value added (current US$) in Kiribati and Value added (current US$) in Mexico?
Provide a short and direct response. -2.80e+1. In the year 2005, what is the difference between the Value added (current US$) of Kiribati and Value added (current US$) of St. Lucia?
Give a very brief answer. -5.03e+06. In the year 2005, what is the difference between the Value added (current US$) in Mexico and Value added (current US$) in St. Lucia?
Provide a short and direct response. 2.79e+1. In the year 2006, what is the difference between the Value added (current US$) in Burundi and Value added (current US$) in Kiribati?
Offer a very short reply. 4.94e+08. In the year 2006, what is the difference between the Value added (current US$) of Burundi and Value added (current US$) of Mexico?
Give a very brief answer. -2.92e+1. In the year 2006, what is the difference between the Value added (current US$) in Burundi and Value added (current US$) in St. Lucia?
Ensure brevity in your answer.  4.85e+08. In the year 2006, what is the difference between the Value added (current US$) in Kiribati and Value added (current US$) in Mexico?
Offer a very short reply. -2.96e+1. In the year 2006, what is the difference between the Value added (current US$) in Kiribati and Value added (current US$) in St. Lucia?
Provide a succinct answer. -9.42e+06. In the year 2006, what is the difference between the Value added (current US$) in Mexico and Value added (current US$) in St. Lucia?
Make the answer very short. 2.96e+1. In the year 2007, what is the difference between the Value added (current US$) of Burundi and Value added (current US$) of Kiribati?
Provide a succinct answer. 4.38e+08. In the year 2007, what is the difference between the Value added (current US$) in Burundi and Value added (current US$) in Mexico?
Ensure brevity in your answer.  -3.25e+1. In the year 2007, what is the difference between the Value added (current US$) of Burundi and Value added (current US$) of St. Lucia?
Ensure brevity in your answer.  4.34e+08. In the year 2007, what is the difference between the Value added (current US$) of Kiribati and Value added (current US$) of Mexico?
Your answer should be compact. -3.29e+1. In the year 2007, what is the difference between the Value added (current US$) of Kiribati and Value added (current US$) of St. Lucia?
Your answer should be compact. -3.94e+06. In the year 2007, what is the difference between the Value added (current US$) in Mexico and Value added (current US$) in St. Lucia?
Offer a terse response. 3.29e+1. In the year 2008, what is the difference between the Value added (current US$) of Burundi and Value added (current US$) of Kiribati?
Offer a very short reply. 5.67e+08. In the year 2008, what is the difference between the Value added (current US$) of Burundi and Value added (current US$) of Mexico?
Offer a very short reply. -3.47e+1. In the year 2008, what is the difference between the Value added (current US$) of Burundi and Value added (current US$) of St. Lucia?
Offer a very short reply. 5.56e+08. In the year 2008, what is the difference between the Value added (current US$) in Kiribati and Value added (current US$) in Mexico?
Your response must be concise. -3.53e+1. In the year 2008, what is the difference between the Value added (current US$) in Kiribati and Value added (current US$) in St. Lucia?
Provide a succinct answer. -1.12e+07. In the year 2008, what is the difference between the Value added (current US$) in Mexico and Value added (current US$) in St. Lucia?
Make the answer very short. 3.53e+1. In the year 2009, what is the difference between the Value added (current US$) in Burundi and Value added (current US$) in Kiribati?
Provide a short and direct response. 6.13e+08. In the year 2009, what is the difference between the Value added (current US$) of Burundi and Value added (current US$) of Mexico?
Your answer should be compact. -2.80e+1. In the year 2009, what is the difference between the Value added (current US$) of Burundi and Value added (current US$) of St. Lucia?
Make the answer very short. 6.01e+08. In the year 2009, what is the difference between the Value added (current US$) in Kiribati and Value added (current US$) in Mexico?
Offer a very short reply. -2.86e+1. In the year 2009, what is the difference between the Value added (current US$) of Kiribati and Value added (current US$) of St. Lucia?
Provide a short and direct response. -1.19e+07. In the year 2009, what is the difference between the Value added (current US$) in Mexico and Value added (current US$) in St. Lucia?
Offer a terse response. 2.86e+1. In the year 2010, what is the difference between the Value added (current US$) in Burundi and Value added (current US$) in Kiribati?
Ensure brevity in your answer.  7.13e+08. In the year 2010, what is the difference between the Value added (current US$) in Burundi and Value added (current US$) in Mexico?
Make the answer very short. -3.29e+1. In the year 2010, what is the difference between the Value added (current US$) of Burundi and Value added (current US$) of St. Lucia?
Offer a very short reply. 7.18e+08. In the year 2010, what is the difference between the Value added (current US$) in Kiribati and Value added (current US$) in Mexico?
Offer a terse response. -3.36e+1. In the year 2010, what is the difference between the Value added (current US$) in Kiribati and Value added (current US$) in St. Lucia?
Make the answer very short. 4.47e+06. In the year 2010, what is the difference between the Value added (current US$) of Mexico and Value added (current US$) of St. Lucia?
Make the answer very short. 3.36e+1. In the year 2011, what is the difference between the Value added (current US$) of Burundi and Value added (current US$) of Kiribati?
Your response must be concise. 8.26e+08. In the year 2011, what is the difference between the Value added (current US$) of Burundi and Value added (current US$) of Mexico?
Give a very brief answer. -3.52e+1. In the year 2011, what is the difference between the Value added (current US$) in Burundi and Value added (current US$) in St. Lucia?
Offer a very short reply. 8.41e+08. In the year 2011, what is the difference between the Value added (current US$) in Kiribati and Value added (current US$) in Mexico?
Offer a very short reply. -3.60e+1. In the year 2011, what is the difference between the Value added (current US$) in Kiribati and Value added (current US$) in St. Lucia?
Your response must be concise. 1.49e+07. In the year 2011, what is the difference between the Value added (current US$) in Mexico and Value added (current US$) in St. Lucia?
Your answer should be very brief. 3.60e+1. In the year 2012, what is the difference between the Value added (current US$) in Burundi and Value added (current US$) in Kiribati?
Your response must be concise. 8.73e+08. In the year 2012, what is the difference between the Value added (current US$) of Burundi and Value added (current US$) of Mexico?
Ensure brevity in your answer.  -3.75e+1. In the year 2012, what is the difference between the Value added (current US$) in Burundi and Value added (current US$) in St. Lucia?
Your response must be concise. 8.84e+08. In the year 2012, what is the difference between the Value added (current US$) of Kiribati and Value added (current US$) of Mexico?
Make the answer very short. -3.84e+1. In the year 2012, what is the difference between the Value added (current US$) in Kiribati and Value added (current US$) in St. Lucia?
Your answer should be very brief. 1.11e+07. In the year 2012, what is the difference between the Value added (current US$) of Mexico and Value added (current US$) of St. Lucia?
Your response must be concise. 3.84e+1. What is the ratio of the Value added (current US$) in Burundi in 2005 to that in 2006?
Ensure brevity in your answer.  0.88. What is the ratio of the Value added (current US$) of Kiribati in 2005 to that in 2006?
Your answer should be compact. 0.99. What is the ratio of the Value added (current US$) in Mexico in 2005 to that in 2006?
Your answer should be very brief. 0.94. What is the ratio of the Value added (current US$) in St. Lucia in 2005 to that in 2006?
Make the answer very short. 0.86. What is the ratio of the Value added (current US$) of Burundi in 2005 to that in 2007?
Your answer should be very brief. 0.98. What is the ratio of the Value added (current US$) in Kiribati in 2005 to that in 2007?
Ensure brevity in your answer.  0.81. What is the ratio of the Value added (current US$) in Mexico in 2005 to that in 2007?
Your answer should be compact. 0.85. What is the ratio of the Value added (current US$) of St. Lucia in 2005 to that in 2007?
Make the answer very short. 0.87. What is the ratio of the Value added (current US$) of Burundi in 2005 to that in 2008?
Give a very brief answer. 0.76. What is the ratio of the Value added (current US$) of Kiribati in 2005 to that in 2008?
Provide a succinct answer. 0.69. What is the ratio of the Value added (current US$) in Mexico in 2005 to that in 2008?
Provide a short and direct response. 0.79. What is the ratio of the Value added (current US$) in St. Lucia in 2005 to that in 2008?
Ensure brevity in your answer.  0.63. What is the ratio of the Value added (current US$) of Burundi in 2005 to that in 2009?
Keep it short and to the point. 0.71. What is the ratio of the Value added (current US$) of Kiribati in 2005 to that in 2009?
Your answer should be compact. 0.75. What is the ratio of the Value added (current US$) in Mexico in 2005 to that in 2009?
Your answer should be compact. 0.98. What is the ratio of the Value added (current US$) in St. Lucia in 2005 to that in 2009?
Your answer should be compact. 0.66. What is the ratio of the Value added (current US$) in Burundi in 2005 to that in 2010?
Provide a succinct answer. 0.61. What is the ratio of the Value added (current US$) in Kiribati in 2005 to that in 2010?
Ensure brevity in your answer.  0.64. What is the ratio of the Value added (current US$) of Mexico in 2005 to that in 2010?
Your answer should be compact. 0.83. What is the ratio of the Value added (current US$) of St. Lucia in 2005 to that in 2010?
Ensure brevity in your answer.  0.89. What is the ratio of the Value added (current US$) in Burundi in 2005 to that in 2011?
Offer a very short reply. 0.53. What is the ratio of the Value added (current US$) in Kiribati in 2005 to that in 2011?
Your answer should be very brief. 0.53. What is the ratio of the Value added (current US$) in Mexico in 2005 to that in 2011?
Give a very brief answer. 0.78. What is the ratio of the Value added (current US$) in St. Lucia in 2005 to that in 2011?
Provide a succinct answer. 0.99. What is the ratio of the Value added (current US$) in Burundi in 2005 to that in 2012?
Your answer should be very brief. 0.5. What is the ratio of the Value added (current US$) in Kiribati in 2005 to that in 2012?
Provide a succinct answer. 0.53. What is the ratio of the Value added (current US$) of Mexico in 2005 to that in 2012?
Keep it short and to the point. 0.73. What is the ratio of the Value added (current US$) in St. Lucia in 2005 to that in 2012?
Your answer should be very brief. 0.86. What is the ratio of the Value added (current US$) of Burundi in 2006 to that in 2007?
Give a very brief answer. 1.11. What is the ratio of the Value added (current US$) in Kiribati in 2006 to that in 2007?
Your answer should be very brief. 0.82. What is the ratio of the Value added (current US$) of Mexico in 2006 to that in 2007?
Make the answer very short. 0.9. What is the ratio of the Value added (current US$) of St. Lucia in 2006 to that in 2007?
Offer a terse response. 1.01. What is the ratio of the Value added (current US$) in Burundi in 2006 to that in 2008?
Ensure brevity in your answer.  0.86. What is the ratio of the Value added (current US$) in Kiribati in 2006 to that in 2008?
Your response must be concise. 0.7. What is the ratio of the Value added (current US$) of Mexico in 2006 to that in 2008?
Give a very brief answer. 0.84. What is the ratio of the Value added (current US$) in St. Lucia in 2006 to that in 2008?
Provide a short and direct response. 0.73. What is the ratio of the Value added (current US$) of Burundi in 2006 to that in 2009?
Offer a terse response. 0.8. What is the ratio of the Value added (current US$) in Kiribati in 2006 to that in 2009?
Your answer should be compact. 0.76. What is the ratio of the Value added (current US$) in Mexico in 2006 to that in 2009?
Ensure brevity in your answer.  1.04. What is the ratio of the Value added (current US$) of St. Lucia in 2006 to that in 2009?
Your response must be concise. 0.77. What is the ratio of the Value added (current US$) in Burundi in 2006 to that in 2010?
Offer a very short reply. 0.69. What is the ratio of the Value added (current US$) in Kiribati in 2006 to that in 2010?
Offer a terse response. 0.64. What is the ratio of the Value added (current US$) of Mexico in 2006 to that in 2010?
Provide a succinct answer. 0.88. What is the ratio of the Value added (current US$) in St. Lucia in 2006 to that in 2010?
Offer a very short reply. 1.03. What is the ratio of the Value added (current US$) of Burundi in 2006 to that in 2011?
Keep it short and to the point. 0.6. What is the ratio of the Value added (current US$) of Kiribati in 2006 to that in 2011?
Make the answer very short. 0.53. What is the ratio of the Value added (current US$) in Mexico in 2006 to that in 2011?
Give a very brief answer. 0.82. What is the ratio of the Value added (current US$) in St. Lucia in 2006 to that in 2011?
Keep it short and to the point. 1.15. What is the ratio of the Value added (current US$) of Burundi in 2006 to that in 2012?
Provide a succinct answer. 0.56. What is the ratio of the Value added (current US$) in Kiribati in 2006 to that in 2012?
Provide a short and direct response. 0.53. What is the ratio of the Value added (current US$) in Mexico in 2006 to that in 2012?
Keep it short and to the point. 0.77. What is the ratio of the Value added (current US$) of St. Lucia in 2006 to that in 2012?
Ensure brevity in your answer.  1. What is the ratio of the Value added (current US$) in Burundi in 2007 to that in 2008?
Your response must be concise. 0.78. What is the ratio of the Value added (current US$) of Kiribati in 2007 to that in 2008?
Your response must be concise. 0.86. What is the ratio of the Value added (current US$) in Mexico in 2007 to that in 2008?
Provide a short and direct response. 0.93. What is the ratio of the Value added (current US$) of St. Lucia in 2007 to that in 2008?
Your answer should be compact. 0.73. What is the ratio of the Value added (current US$) in Burundi in 2007 to that in 2009?
Provide a short and direct response. 0.72. What is the ratio of the Value added (current US$) of Kiribati in 2007 to that in 2009?
Offer a terse response. 0.93. What is the ratio of the Value added (current US$) of Mexico in 2007 to that in 2009?
Ensure brevity in your answer.  1.15. What is the ratio of the Value added (current US$) of St. Lucia in 2007 to that in 2009?
Ensure brevity in your answer.  0.76. What is the ratio of the Value added (current US$) in Burundi in 2007 to that in 2010?
Ensure brevity in your answer.  0.62. What is the ratio of the Value added (current US$) in Kiribati in 2007 to that in 2010?
Provide a succinct answer. 0.79. What is the ratio of the Value added (current US$) in Mexico in 2007 to that in 2010?
Provide a short and direct response. 0.98. What is the ratio of the Value added (current US$) in St. Lucia in 2007 to that in 2010?
Provide a succinct answer. 1.02. What is the ratio of the Value added (current US$) in Burundi in 2007 to that in 2011?
Your answer should be very brief. 0.54. What is the ratio of the Value added (current US$) in Kiribati in 2007 to that in 2011?
Your answer should be very brief. 0.65. What is the ratio of the Value added (current US$) in Mexico in 2007 to that in 2011?
Offer a very short reply. 0.91. What is the ratio of the Value added (current US$) of St. Lucia in 2007 to that in 2011?
Keep it short and to the point. 1.14. What is the ratio of the Value added (current US$) of Burundi in 2007 to that in 2012?
Make the answer very short. 0.51. What is the ratio of the Value added (current US$) in Kiribati in 2007 to that in 2012?
Provide a short and direct response. 0.65. What is the ratio of the Value added (current US$) of Mexico in 2007 to that in 2012?
Ensure brevity in your answer.  0.86. What is the ratio of the Value added (current US$) in St. Lucia in 2007 to that in 2012?
Offer a very short reply. 1. What is the ratio of the Value added (current US$) of Burundi in 2008 to that in 2009?
Ensure brevity in your answer.  0.93. What is the ratio of the Value added (current US$) in Kiribati in 2008 to that in 2009?
Make the answer very short. 1.08. What is the ratio of the Value added (current US$) of Mexico in 2008 to that in 2009?
Keep it short and to the point. 1.23. What is the ratio of the Value added (current US$) of St. Lucia in 2008 to that in 2009?
Your answer should be compact. 1.04. What is the ratio of the Value added (current US$) in Burundi in 2008 to that in 2010?
Make the answer very short. 0.8. What is the ratio of the Value added (current US$) of Kiribati in 2008 to that in 2010?
Offer a very short reply. 0.92. What is the ratio of the Value added (current US$) in Mexico in 2008 to that in 2010?
Keep it short and to the point. 1.05. What is the ratio of the Value added (current US$) in St. Lucia in 2008 to that in 2010?
Ensure brevity in your answer.  1.4. What is the ratio of the Value added (current US$) of Burundi in 2008 to that in 2011?
Ensure brevity in your answer.  0.69. What is the ratio of the Value added (current US$) of Kiribati in 2008 to that in 2011?
Your answer should be compact. 0.76. What is the ratio of the Value added (current US$) in Mexico in 2008 to that in 2011?
Ensure brevity in your answer.  0.98. What is the ratio of the Value added (current US$) in St. Lucia in 2008 to that in 2011?
Your response must be concise. 1.56. What is the ratio of the Value added (current US$) of Burundi in 2008 to that in 2012?
Your response must be concise. 0.65. What is the ratio of the Value added (current US$) in Kiribati in 2008 to that in 2012?
Make the answer very short. 0.76. What is the ratio of the Value added (current US$) of Mexico in 2008 to that in 2012?
Your response must be concise. 0.92. What is the ratio of the Value added (current US$) in St. Lucia in 2008 to that in 2012?
Provide a short and direct response. 1.37. What is the ratio of the Value added (current US$) in Burundi in 2009 to that in 2010?
Your response must be concise. 0.86. What is the ratio of the Value added (current US$) in Kiribati in 2009 to that in 2010?
Give a very brief answer. 0.85. What is the ratio of the Value added (current US$) in Mexico in 2009 to that in 2010?
Keep it short and to the point. 0.85. What is the ratio of the Value added (current US$) of St. Lucia in 2009 to that in 2010?
Provide a short and direct response. 1.34. What is the ratio of the Value added (current US$) in Burundi in 2009 to that in 2011?
Give a very brief answer. 0.74. What is the ratio of the Value added (current US$) of Kiribati in 2009 to that in 2011?
Provide a short and direct response. 0.71. What is the ratio of the Value added (current US$) in Mexico in 2009 to that in 2011?
Offer a terse response. 0.79. What is the ratio of the Value added (current US$) in St. Lucia in 2009 to that in 2011?
Your answer should be very brief. 1.5. What is the ratio of the Value added (current US$) in Burundi in 2009 to that in 2012?
Provide a succinct answer. 0.7. What is the ratio of the Value added (current US$) in Kiribati in 2009 to that in 2012?
Give a very brief answer. 0.7. What is the ratio of the Value added (current US$) in Mexico in 2009 to that in 2012?
Make the answer very short. 0.75. What is the ratio of the Value added (current US$) in St. Lucia in 2009 to that in 2012?
Give a very brief answer. 1.31. What is the ratio of the Value added (current US$) of Burundi in 2010 to that in 2011?
Give a very brief answer. 0.86. What is the ratio of the Value added (current US$) of Kiribati in 2010 to that in 2011?
Your response must be concise. 0.83. What is the ratio of the Value added (current US$) in Mexico in 2010 to that in 2011?
Offer a terse response. 0.93. What is the ratio of the Value added (current US$) in St. Lucia in 2010 to that in 2011?
Your answer should be very brief. 1.11. What is the ratio of the Value added (current US$) of Burundi in 2010 to that in 2012?
Your response must be concise. 0.82. What is the ratio of the Value added (current US$) of Kiribati in 2010 to that in 2012?
Keep it short and to the point. 0.83. What is the ratio of the Value added (current US$) in Mexico in 2010 to that in 2012?
Ensure brevity in your answer.  0.88. What is the ratio of the Value added (current US$) of St. Lucia in 2010 to that in 2012?
Offer a very short reply. 0.97. What is the ratio of the Value added (current US$) of Burundi in 2011 to that in 2012?
Give a very brief answer. 0.95. What is the ratio of the Value added (current US$) in Kiribati in 2011 to that in 2012?
Provide a short and direct response. 1. What is the ratio of the Value added (current US$) of Mexico in 2011 to that in 2012?
Give a very brief answer. 0.94. What is the difference between the highest and the second highest Value added (current US$) in Burundi?
Ensure brevity in your answer.  4.72e+07. What is the difference between the highest and the second highest Value added (current US$) of Kiribati?
Ensure brevity in your answer.  1.66e+05. What is the difference between the highest and the second highest Value added (current US$) in Mexico?
Your answer should be compact. 2.33e+09. What is the difference between the highest and the second highest Value added (current US$) of St. Lucia?
Provide a short and direct response. 1.83e+06. What is the difference between the highest and the lowest Value added (current US$) in Burundi?
Offer a very short reply. 4.60e+08. What is the difference between the highest and the lowest Value added (current US$) of Kiribati?
Offer a very short reply. 2.05e+07. What is the difference between the highest and the lowest Value added (current US$) in Mexico?
Give a very brief answer. 1.04e+1. What is the difference between the highest and the lowest Value added (current US$) of St. Lucia?
Keep it short and to the point. 1.63e+07. 